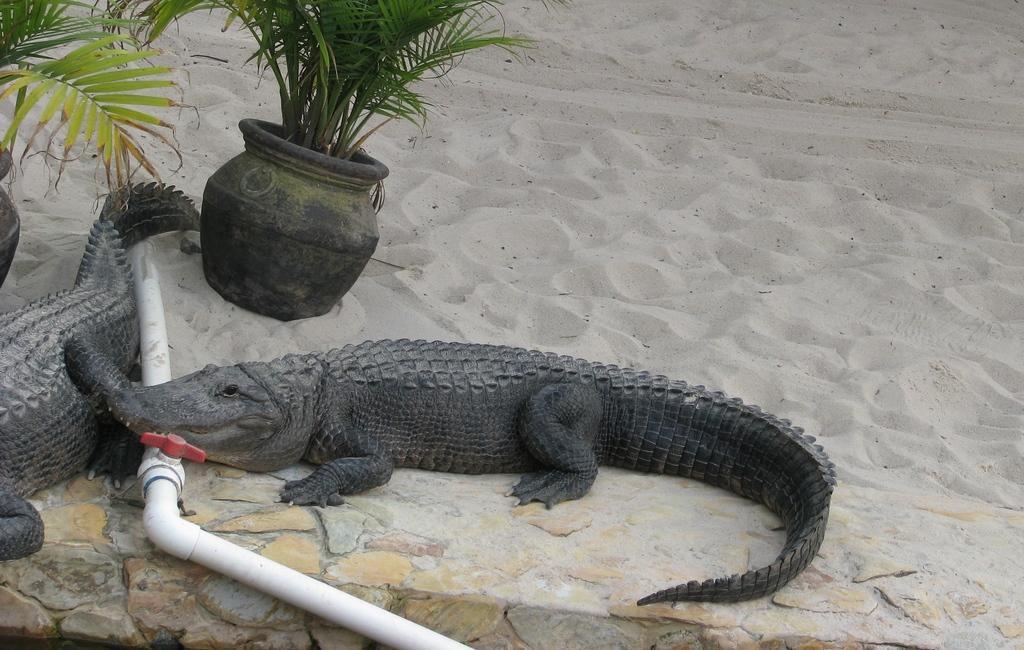How would you summarize this image in a sentence or two? On the left side, there are two potted plants and two crocodiles on a sand surface, near a white color pipe. In the background, there is sand surface. 